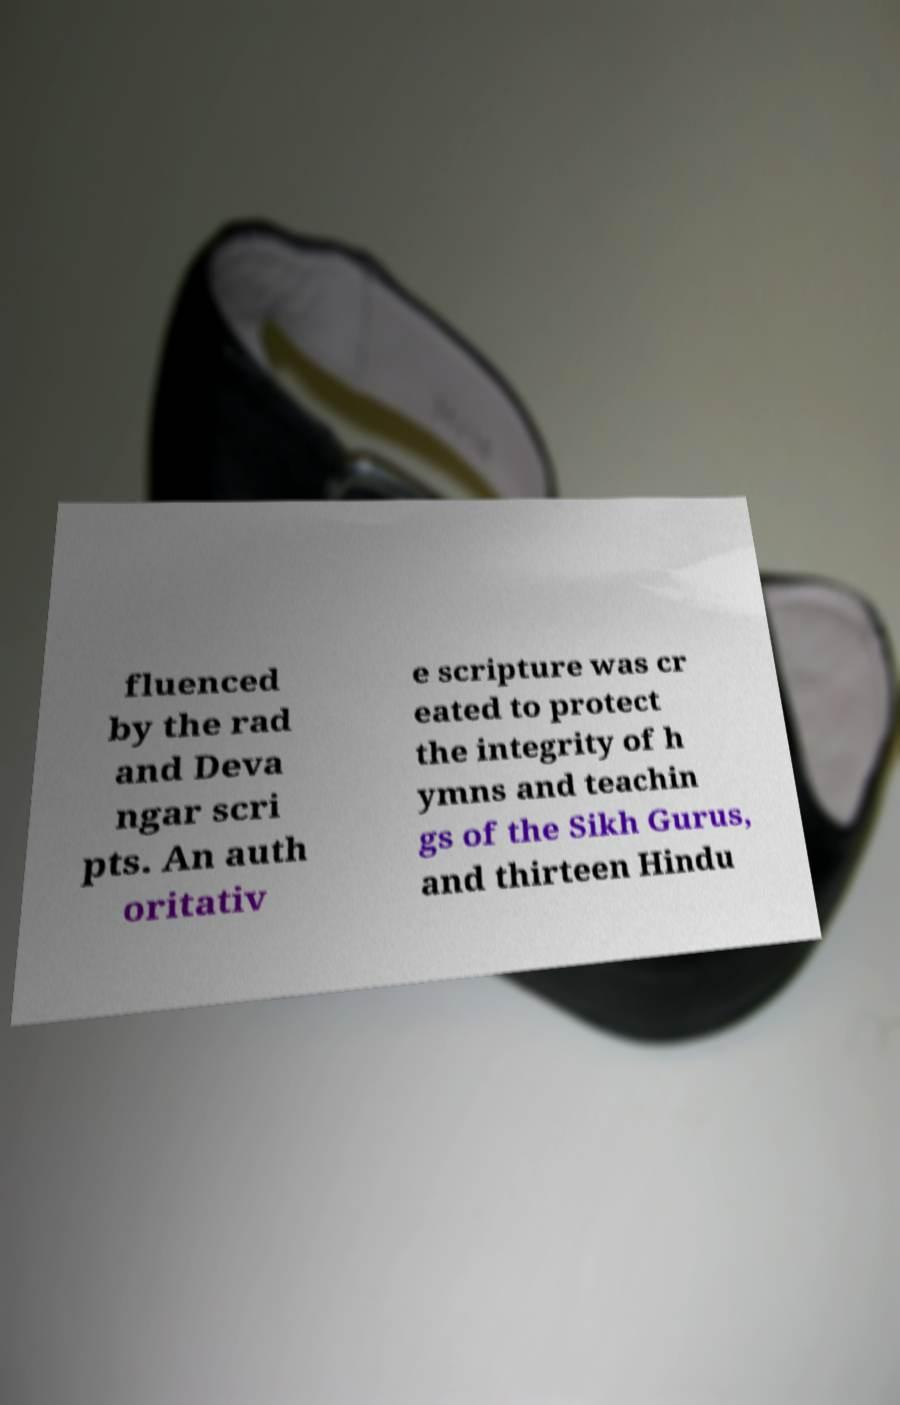Could you extract and type out the text from this image? fluenced by the rad and Deva ngar scri pts. An auth oritativ e scripture was cr eated to protect the integrity of h ymns and teachin gs of the Sikh Gurus, and thirteen Hindu 